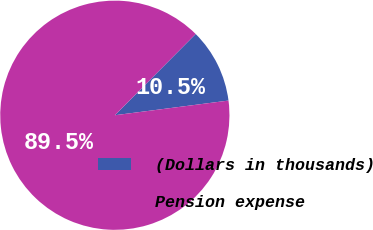<chart> <loc_0><loc_0><loc_500><loc_500><pie_chart><fcel>(Dollars in thousands)<fcel>Pension expense<nl><fcel>10.5%<fcel>89.5%<nl></chart> 